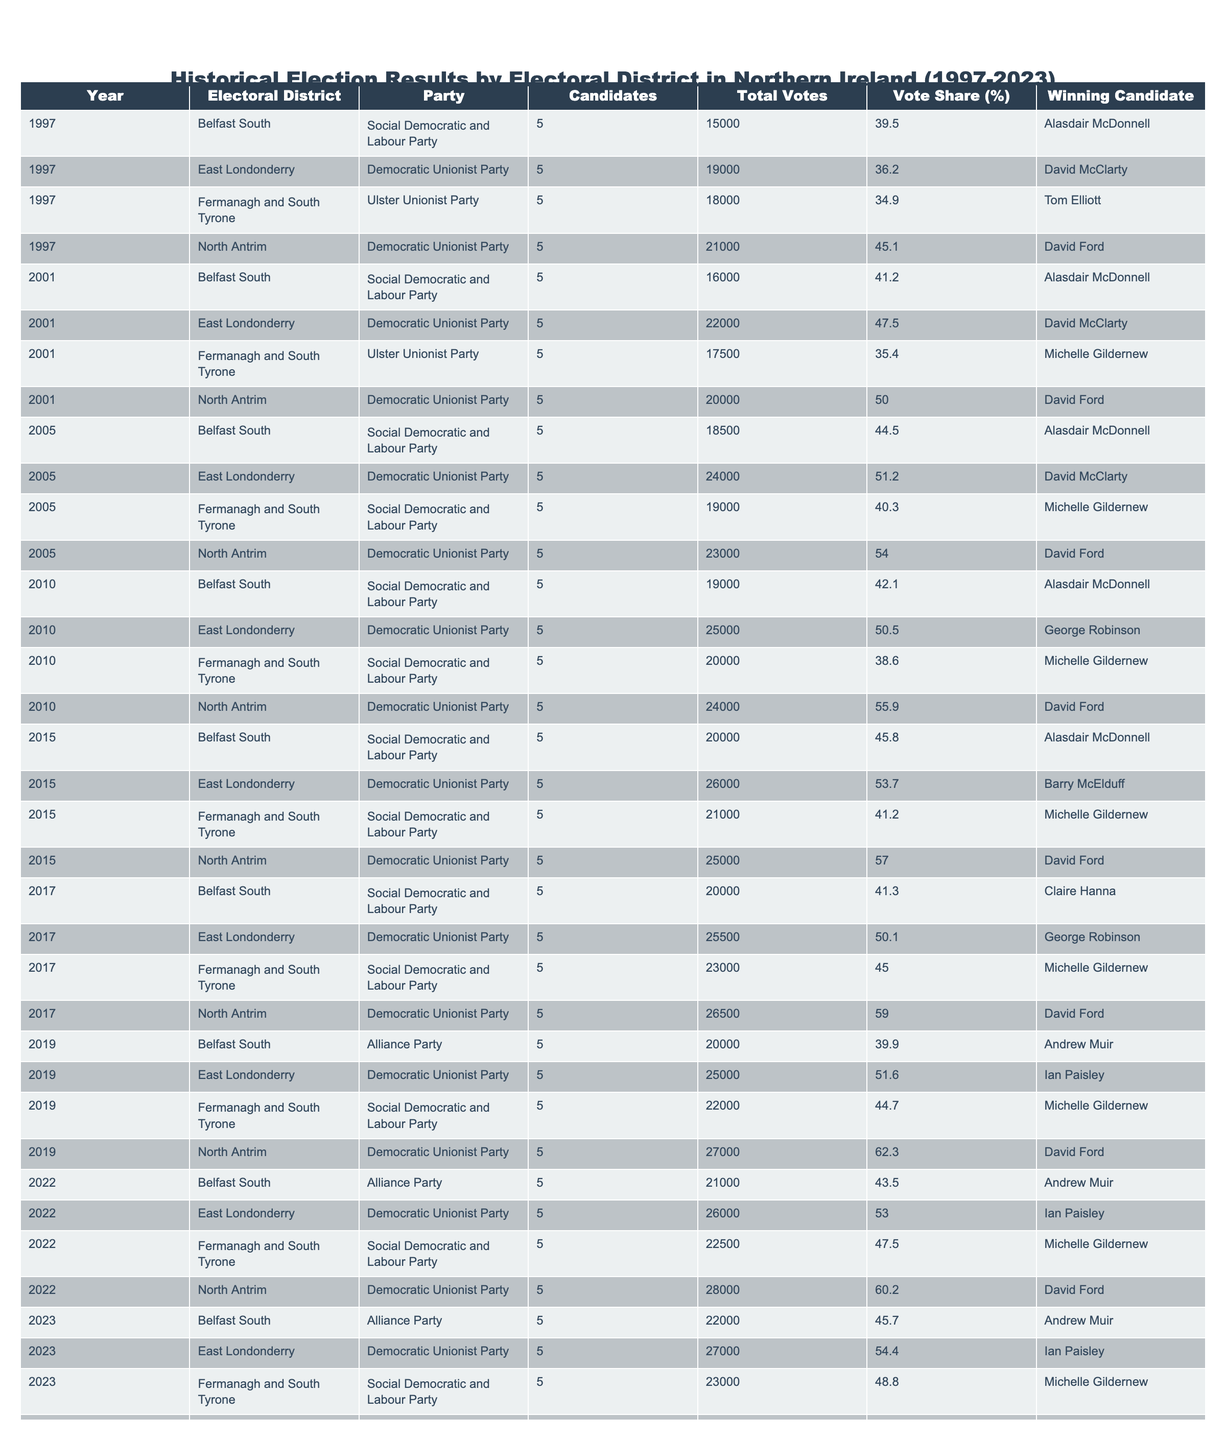What was the winning party in the Belfast South electoral district in 1997? The table shows that in 1997, the winning party for the Belfast South electoral district was the Social Democratic and Labour Party.
Answer: Social Democratic and Labour Party Which electoral district had the highest vote share in 2019? In 2019, North Antrim had the highest vote share at 62.3%.
Answer: North Antrim What is the total number of votes cast in the East Londonderry electoral district from 2001 to 2023? The votes in East Londonderry from 2001 to 2023 are: 22000 in 2001, 24000 in 2005, 25000 in 2010, 26000 in 2015, 25500 in 2017, 25000 in 2019, 26000 in 2022, and 27000 in 2023. Adding these gives a total of 22000 + 24000 + 25000 + 26000 + 25500 + 25000 + 26000 + 27000 = 205500.
Answer: 205500 How many different parties won in the Fermanagh and South Tyrone electoral district between 1997 and 2023? Reviewing the table, the parties that won in Fermanagh and South Tyrone during those years were the Ulster Unionist Party in 1997, the Social Democratic and Labour Party in 2005, and again in 2010, and the same party in 2015, and finally, the same party in 2019, 2022, and 2023. This totals to two different parties winning: the Ulster Unionist Party and the Social Democratic and Labour Party.
Answer: Two In which year did the Democratic Unionist Party first achieve a vote share above 50% in North Antrim? Looking at the table, the Democratic Unionist Party achieved a vote share above 50% in North Antrim for the first time in the year 2001 with a 50.0% share.
Answer: 2001 What was the difference in total votes for the winning candidate in Belfast South from 1997 to 2023? In 1997, the winning candidate received 15000 votes and in 2023 the winning candidate received 22000 votes. The difference is 22000 - 15000 = 7000 votes.
Answer: 7000 Has the Social Democratic and Labour Party won in the Fermanagh and South Tyrone district for more years than the Ulster Unionist Party from 1997 to 2023? The Social Democratic and Labour Party won in Fermanagh and South Tyrone three times (2005, 2010, 2015, 2019, 2022, and 2023), compared to the Ulster Unionist Party, which won once in 1997. Thus, yes, the Social Democratic and Labour Party won more years.
Answer: Yes What is the average vote share for the Democratic Unionist Party in North Antrim from 2001 to 2023? The Democratic Unionist Party achieved the following vote shares in North Antrim: 50.0% in 2001, 54.0% in 2005, 55.9% in 2010, 57.0% in 2015, 59.0% in 2017, 62.3% in 2019, 60.2% in 2022, and 62.0% in 2023. Adding these shares gives a total of 50.0 + 54.0 + 55.9 + 57.0 + 59.0 + 62.3 + 60.2 + 62.0 = 408.4, which divided by 8 yields an average of 51.05%.
Answer: 51.05% 